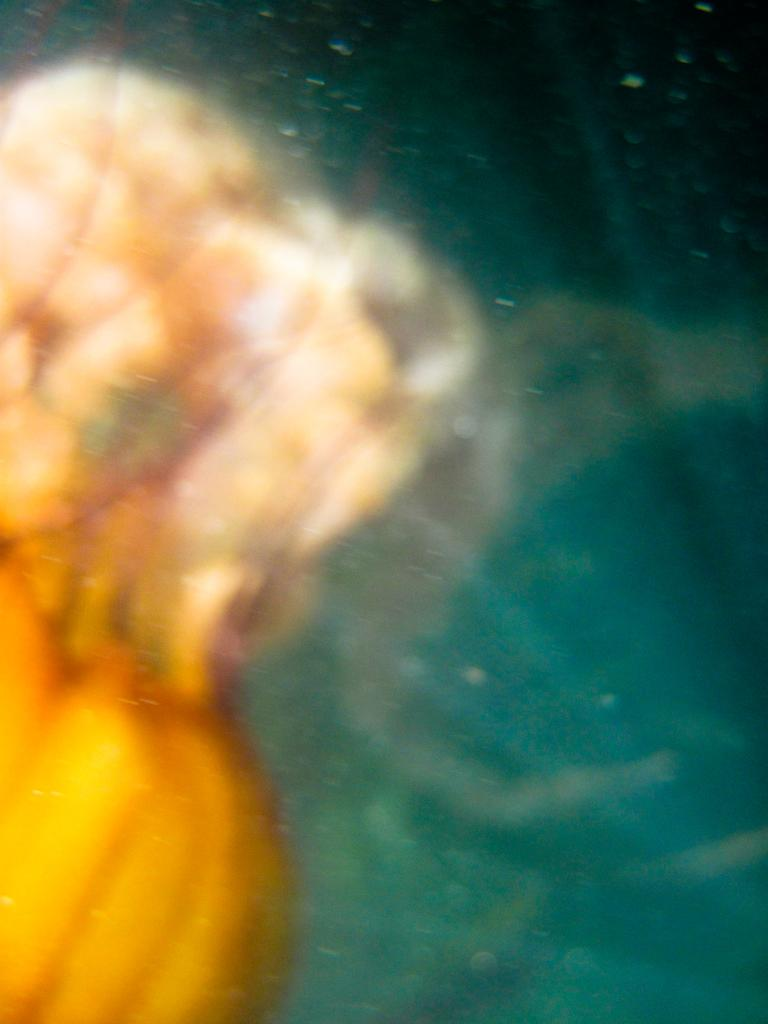What is the primary element visible in the image? There is water in the image. Are there any living organisms present in the water? There might be sea creatures in the water. Can you describe the object on the left side of the image? There is a yellow object on the left side of the image. How far away is the airport from the water in the image? There is no airport present in the image, so it is not possible to determine the distance between the water and an airport. 